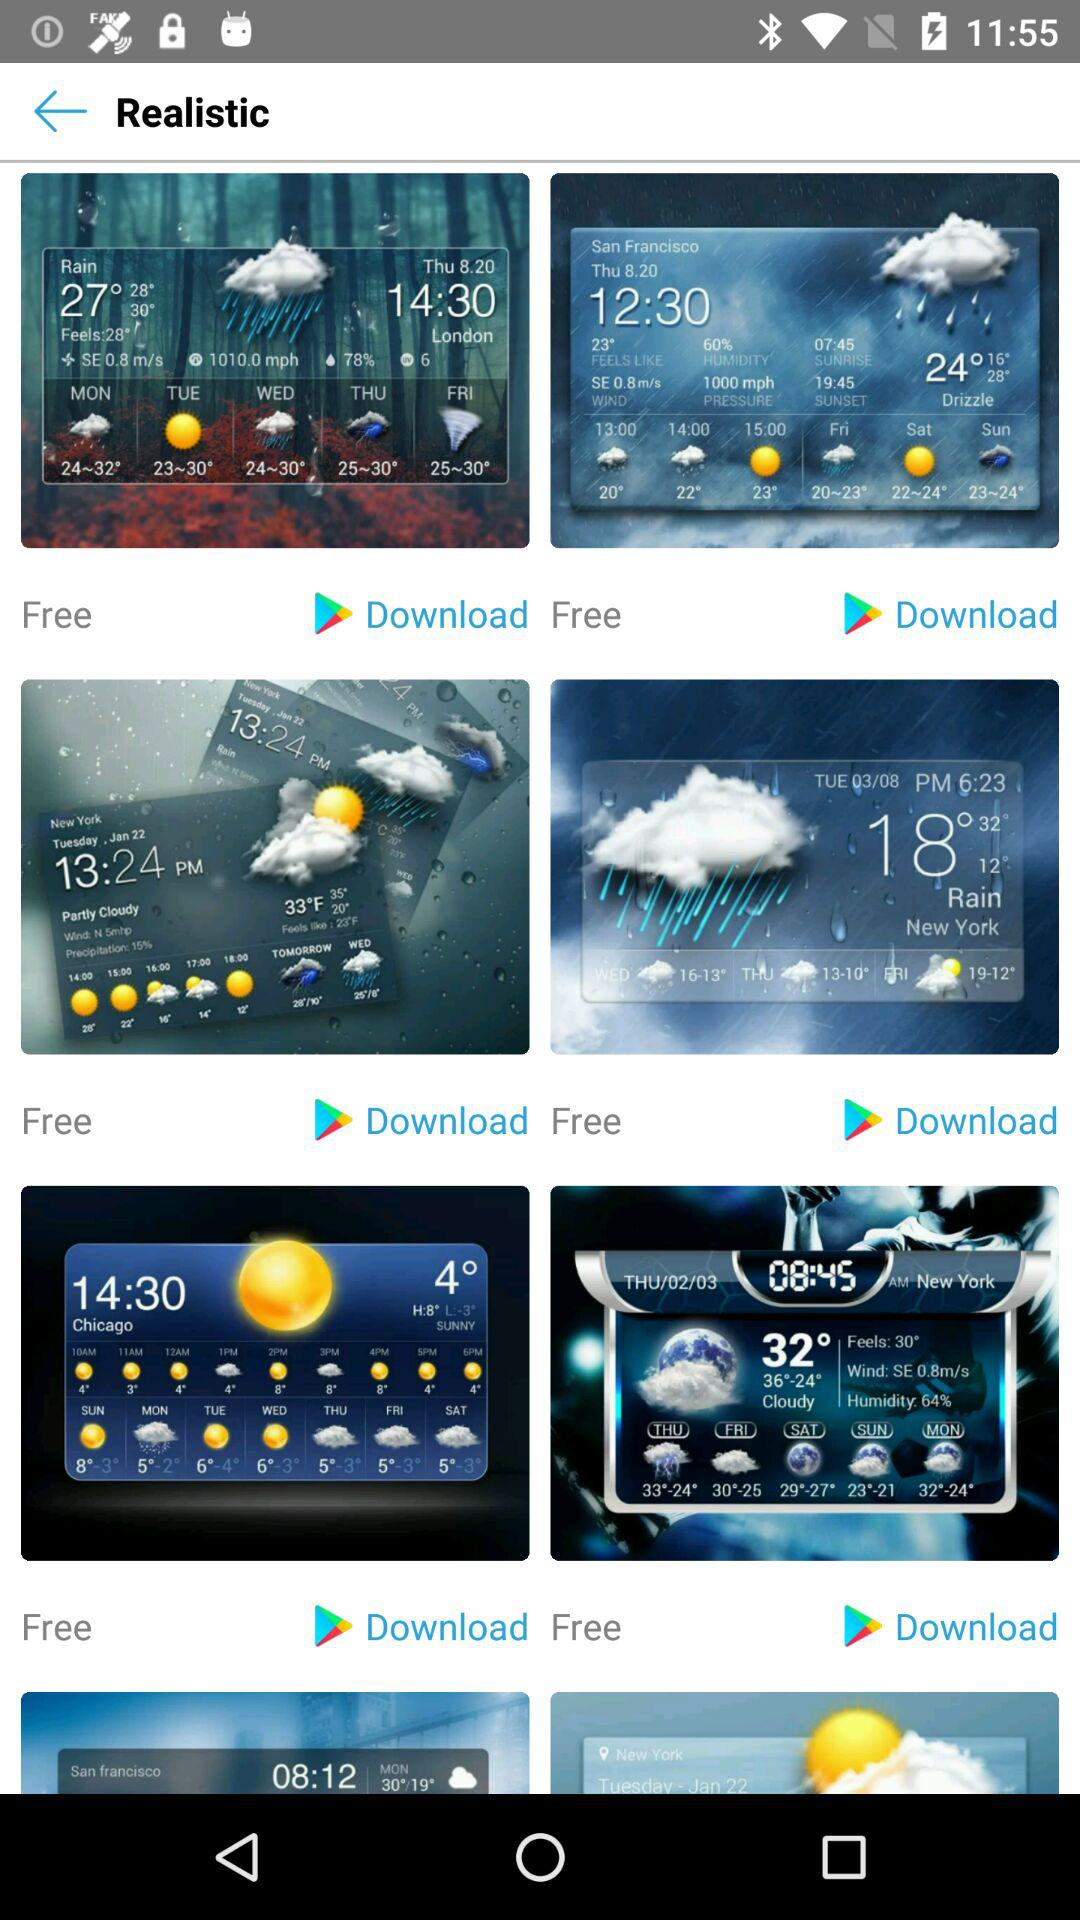How many more weather apps are there for New York than for San Francisco?
Answer the question using a single word or phrase. 2 